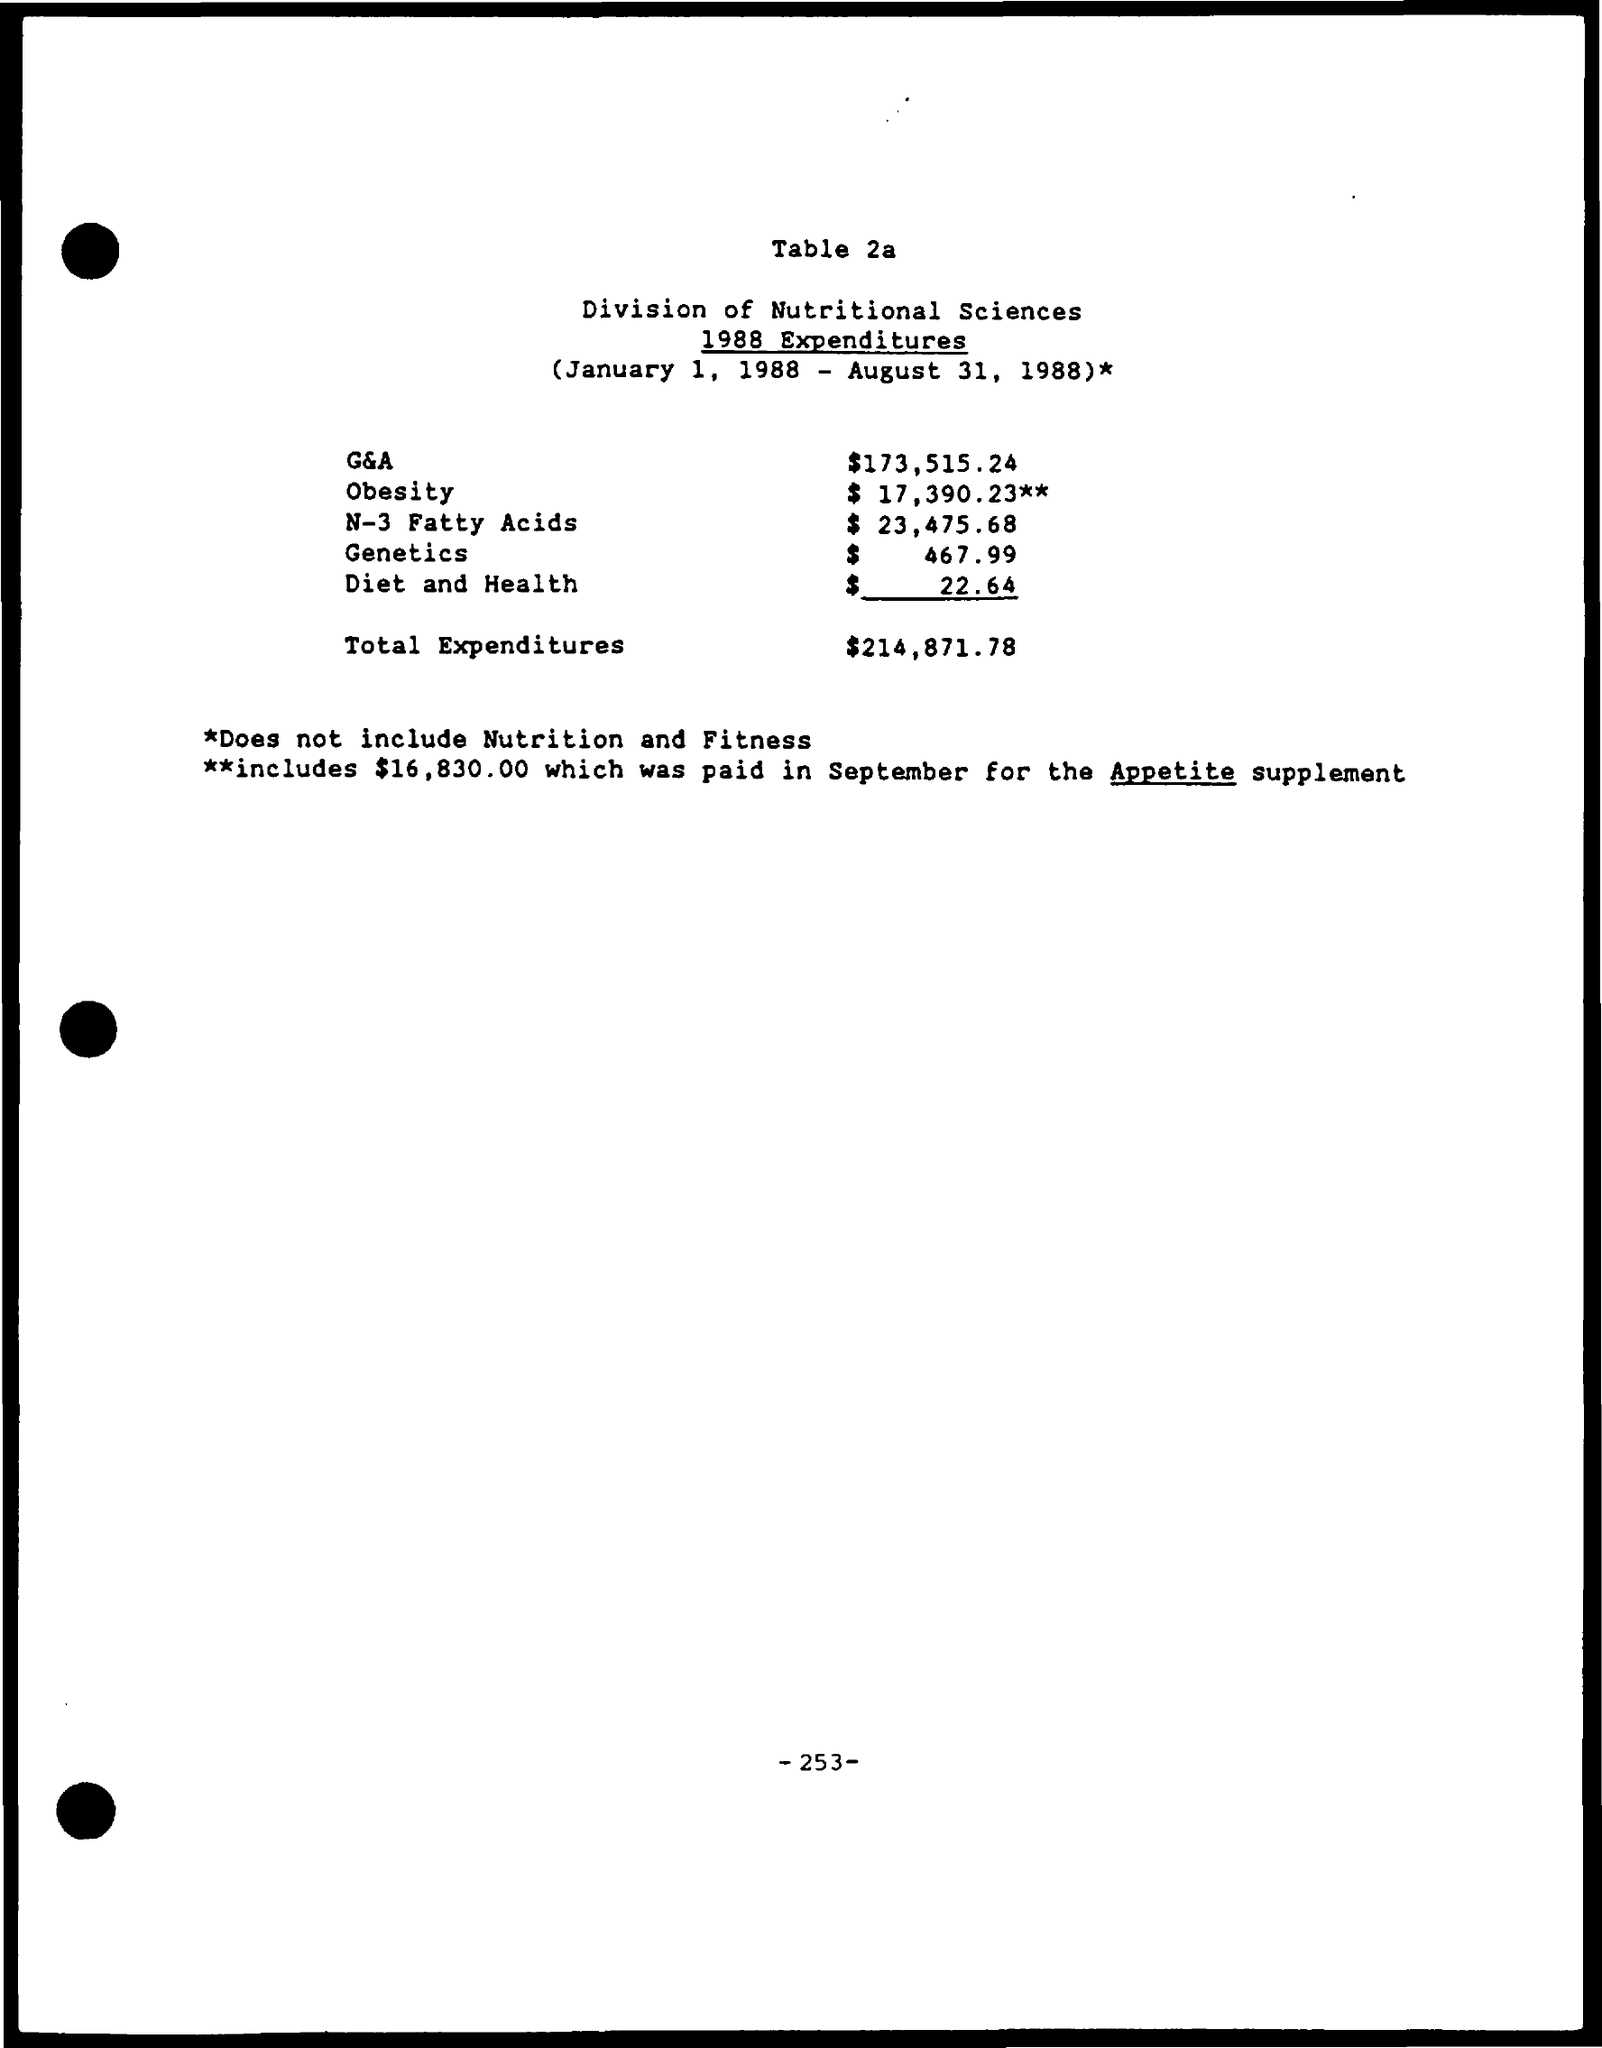What is the G&A?
Offer a very short reply. 173,515.24. What is the Expenditure for obesity?
Give a very brief answer. 17,390.23. What is the Expenditure for N-3 Fatty Acids?
Your response must be concise. 23,475.68. What is the Expenditure for Genetics?
Keep it short and to the point. $   467.99. What is the Expenditure for Diet and Health?
Offer a very short reply. $22.64. What is the Total Expenditures?
Your response must be concise. $214,871.78. 